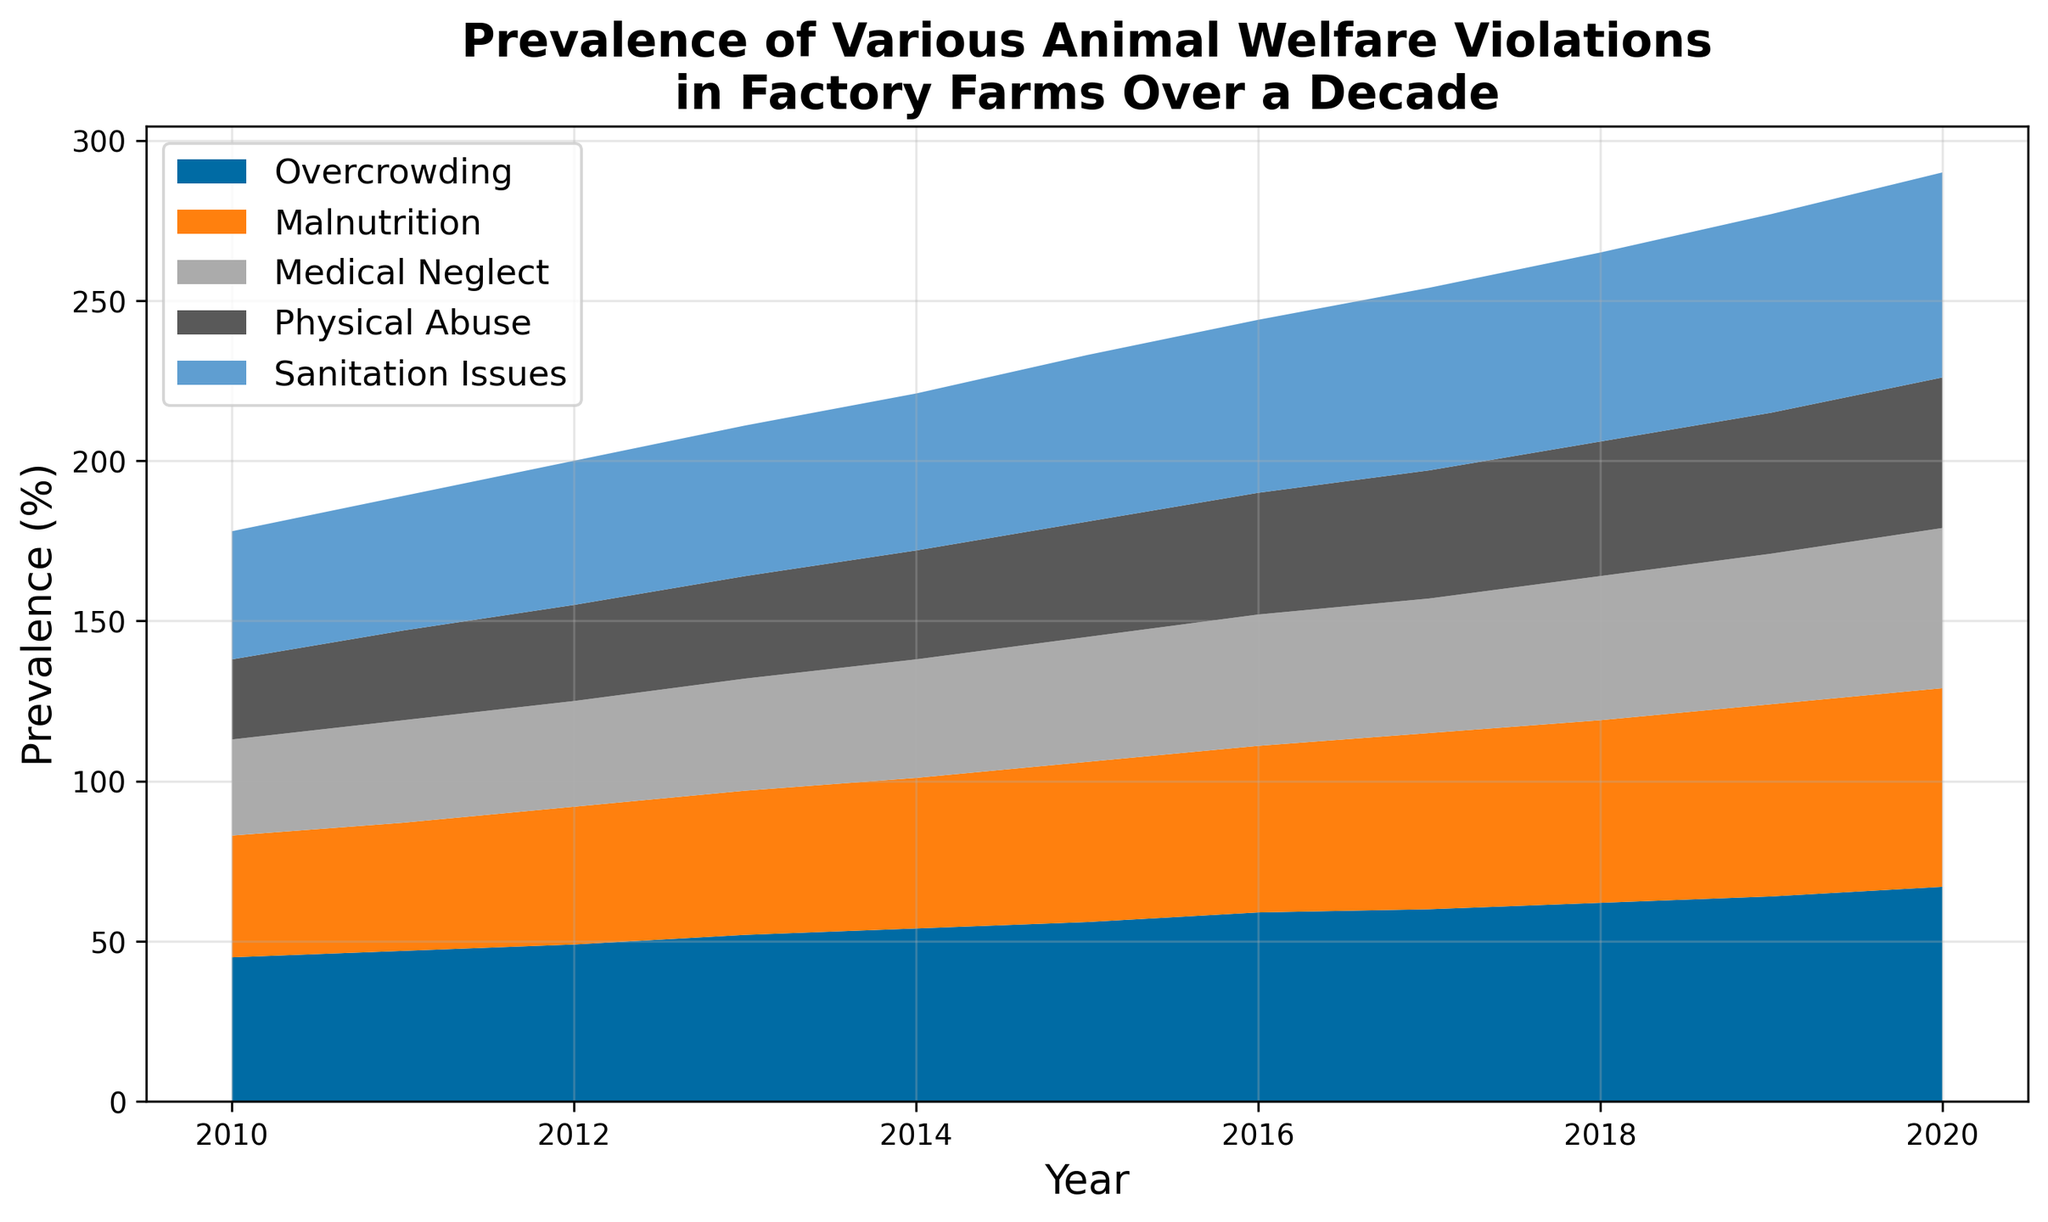What is the overall trend in the prevalence of overcrowding from 2010 to 2020? The area chart shows sustained increasing values for overcrowding from 2010 to 2020. At each year point, the prevalence percentage rises continuously without any decrease or plateau.
Answer: Increasing Which animal welfare violation had the second highest prevalence in 2018? By observing the stacked layers of the area chart for 2018, the second highest layer from the bottom up is malnutrition.
Answer: Malnutrition How much did the prevalence of physical abuse increase from 2010 to 2020? In 2010, physical abuse was at 25%. By 2020, it increased to 47%. Subtracting these gives the increase: 47% - 25% = 22%.
Answer: 22% Between which years did the prevalence of sanitation issues witness the highest increase? By examining the slope of sanitation issues layer, the steepest increase is noted between 2014 and 2015, rising from 49% to 52%, indicating a 3% rise.
Answer: 2014 to 2015 Looking at the area representing medical neglect, in what year did it first reach above 40% prevalence? Observing the medical neglect layer, we see it surpassing the 40% mark between 2015 and 2016 for the first time.
Answer: 2016 In 2020, was the prevalence of malnutrition greater than medical neglect? Referring to the specific year 2020, the height for malnutrition layer is at 62% while medical neglect is at 50%, meaning malnutrition is greater.
Answer: Yes Which violation consistently had the highest prevalence throughout the decade? By observing the layered structure each year, the bottom-most layer representing overcrowding consistently maintains the highest segment, indicating the highest prevalence.
Answer: Overcrowding Calculate the average prevalence of physical abuse over the 10-year period. Summing the prevalence of physical abuse from 2010 to 2020 gives: 25 + 28 + 30 + 32 + 34 + 36 + 38 + 40 + 42 + 44 + 47 = 396. Dividing by 11 years results in 396/11 ≈ 36%.
Answer: 36% What is the combined prevalence percentage of malnutrition and sanitation issues in 2015? Adding the malnutrition (50%) and sanitation issues (52%) layers for the year 2015 results in: 50% + 52% = 102%.
Answer: 102% In what way can the trend of medical neglect from 2010 to 2020 be described as different from physical abuse? While both violations show an increasing trend, the slope of the increase (rate of change per year) in medical neglect is steadier and somewhat less steep compared to physical abuse, particularly noticeable from 2015 onwards.
Answer: Steadier, less steep 